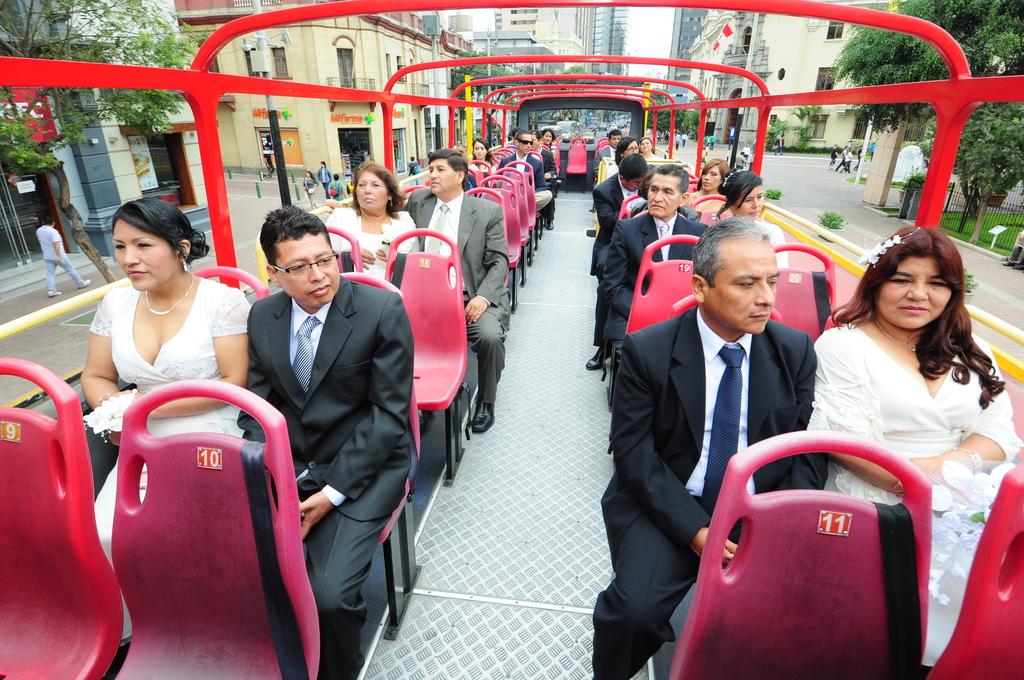What is the seat number on the bottom right?
Offer a terse response. 11. What is the seat number in front of the man on the left side?
Keep it short and to the point. 10. 